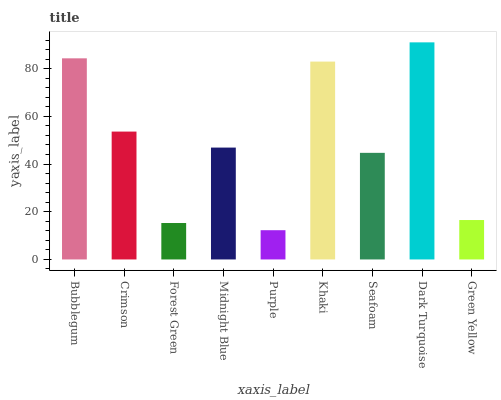Is Purple the minimum?
Answer yes or no. Yes. Is Dark Turquoise the maximum?
Answer yes or no. Yes. Is Crimson the minimum?
Answer yes or no. No. Is Crimson the maximum?
Answer yes or no. No. Is Bubblegum greater than Crimson?
Answer yes or no. Yes. Is Crimson less than Bubblegum?
Answer yes or no. Yes. Is Crimson greater than Bubblegum?
Answer yes or no. No. Is Bubblegum less than Crimson?
Answer yes or no. No. Is Midnight Blue the high median?
Answer yes or no. Yes. Is Midnight Blue the low median?
Answer yes or no. Yes. Is Bubblegum the high median?
Answer yes or no. No. Is Purple the low median?
Answer yes or no. No. 